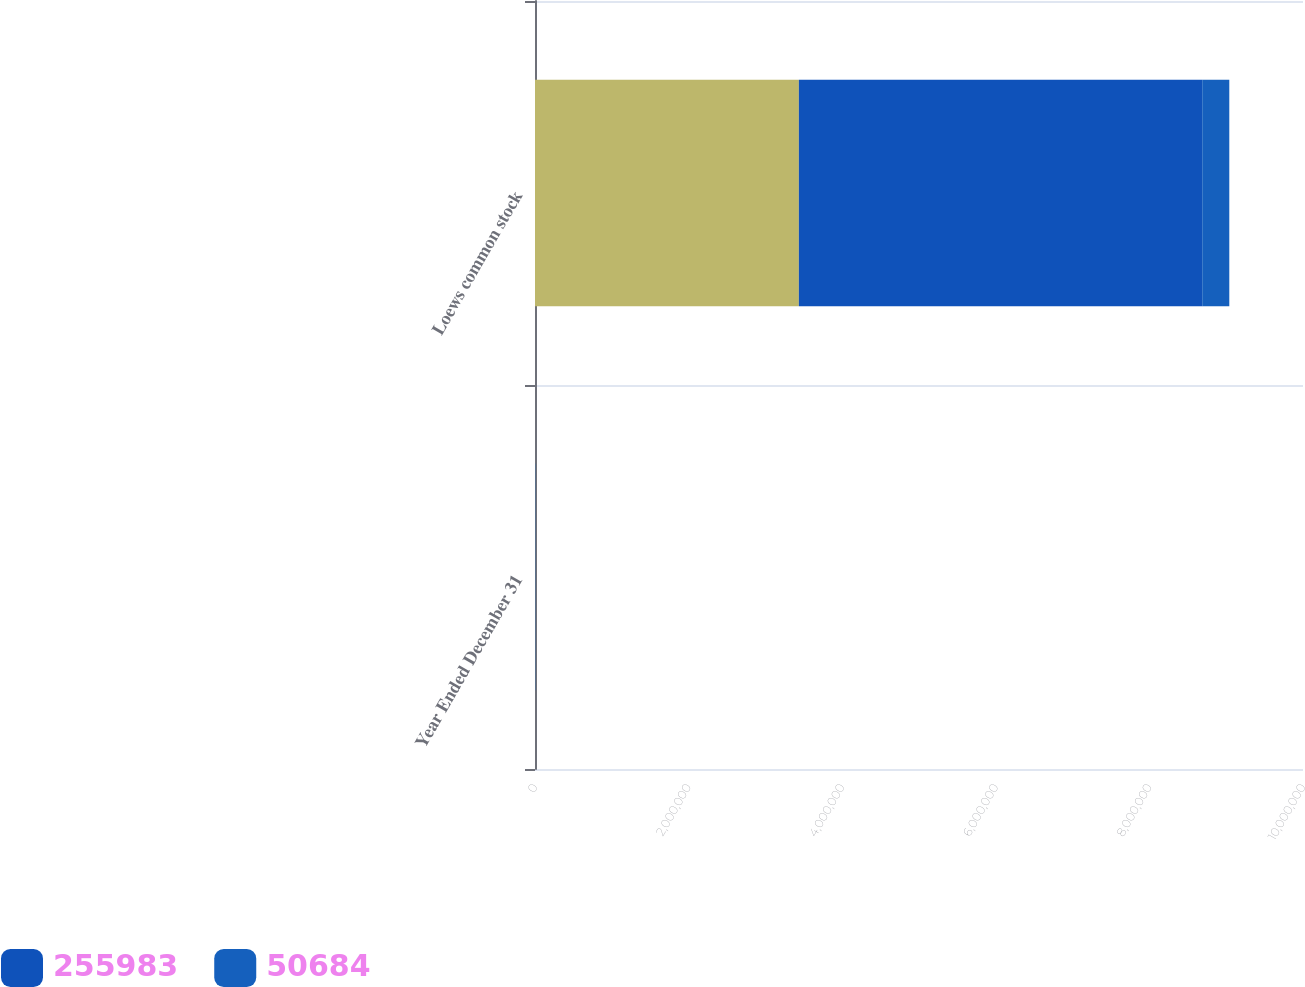<chart> <loc_0><loc_0><loc_500><loc_500><stacked_bar_chart><ecel><fcel>Year Ended December 31<fcel>Loews common stock<nl><fcel>nan<fcel>2009<fcel>3.43578e+06<nl><fcel>255983<fcel>2008<fcel>5.25201e+06<nl><fcel>50684<fcel>2007<fcel>352583<nl></chart> 